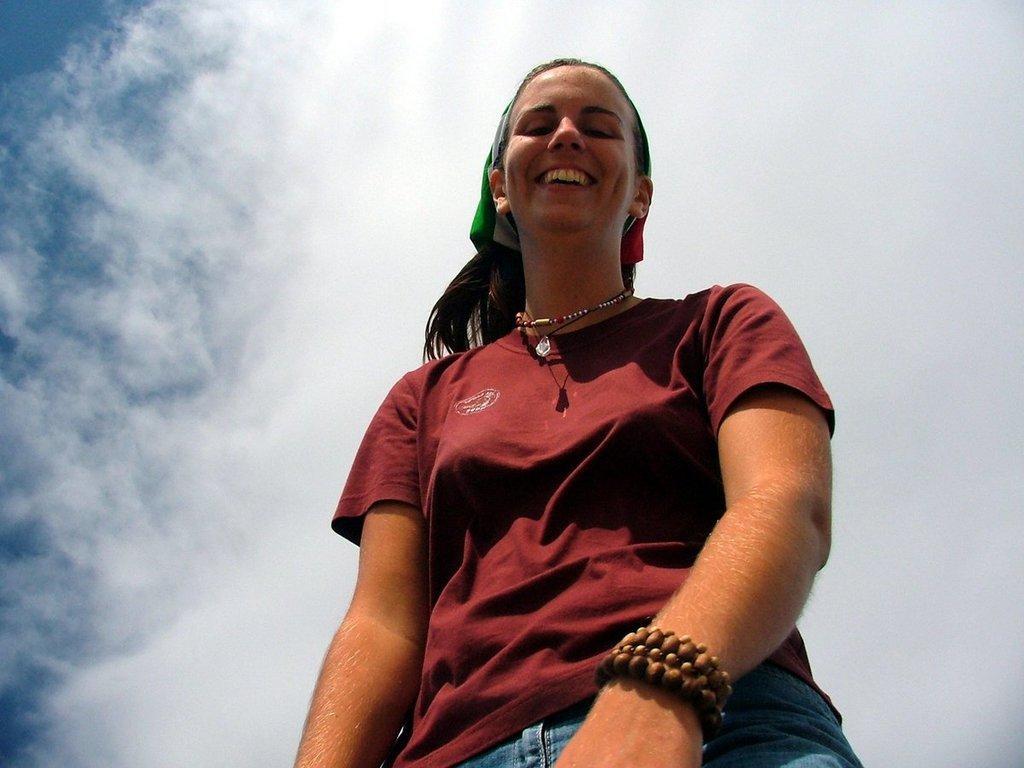Could you give a brief overview of what you see in this image? In this image there is a lady, she is wearing T-shirt and jeans, in the background there is the sky. 